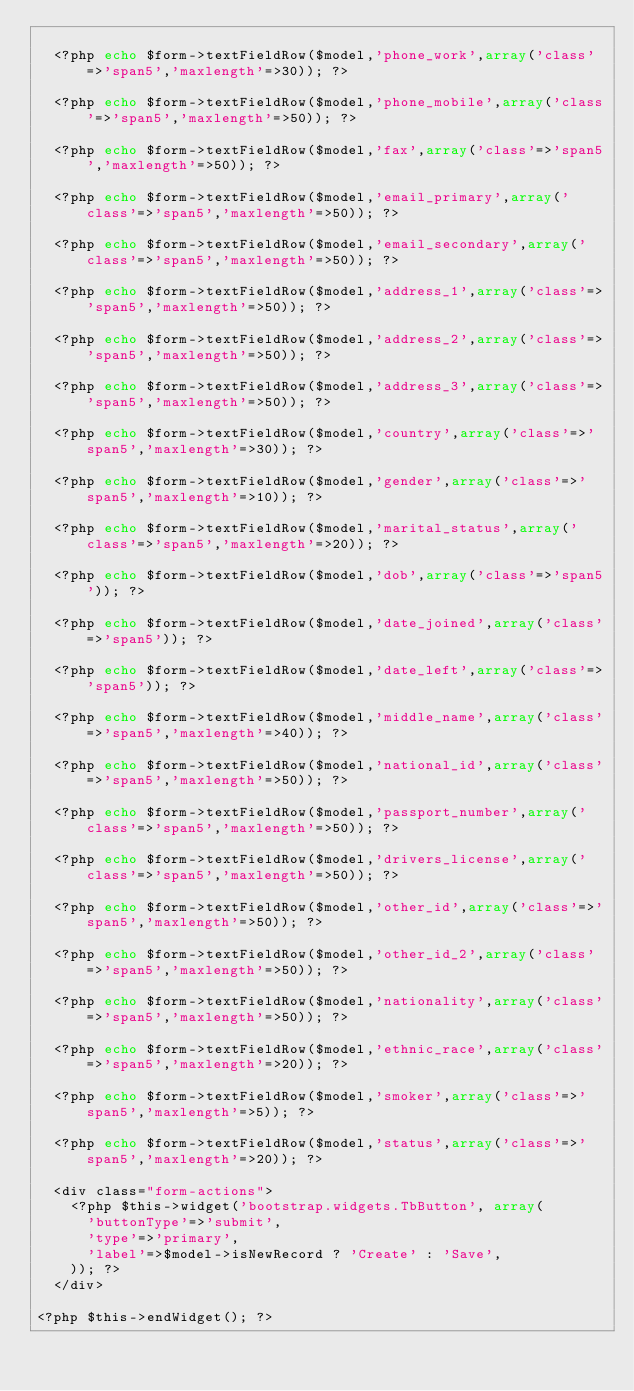<code> <loc_0><loc_0><loc_500><loc_500><_PHP_>
	<?php echo $form->textFieldRow($model,'phone_work',array('class'=>'span5','maxlength'=>30)); ?>

	<?php echo $form->textFieldRow($model,'phone_mobile',array('class'=>'span5','maxlength'=>50)); ?>

	<?php echo $form->textFieldRow($model,'fax',array('class'=>'span5','maxlength'=>50)); ?>

	<?php echo $form->textFieldRow($model,'email_primary',array('class'=>'span5','maxlength'=>50)); ?>

	<?php echo $form->textFieldRow($model,'email_secondary',array('class'=>'span5','maxlength'=>50)); ?>

	<?php echo $form->textFieldRow($model,'address_1',array('class'=>'span5','maxlength'=>50)); ?>

	<?php echo $form->textFieldRow($model,'address_2',array('class'=>'span5','maxlength'=>50)); ?>

	<?php echo $form->textFieldRow($model,'address_3',array('class'=>'span5','maxlength'=>50)); ?>

	<?php echo $form->textFieldRow($model,'country',array('class'=>'span5','maxlength'=>30)); ?>

	<?php echo $form->textFieldRow($model,'gender',array('class'=>'span5','maxlength'=>10)); ?>

	<?php echo $form->textFieldRow($model,'marital_status',array('class'=>'span5','maxlength'=>20)); ?>

	<?php echo $form->textFieldRow($model,'dob',array('class'=>'span5')); ?>

	<?php echo $form->textFieldRow($model,'date_joined',array('class'=>'span5')); ?>

	<?php echo $form->textFieldRow($model,'date_left',array('class'=>'span5')); ?>

	<?php echo $form->textFieldRow($model,'middle_name',array('class'=>'span5','maxlength'=>40)); ?>

	<?php echo $form->textFieldRow($model,'national_id',array('class'=>'span5','maxlength'=>50)); ?>

	<?php echo $form->textFieldRow($model,'passport_number',array('class'=>'span5','maxlength'=>50)); ?>

	<?php echo $form->textFieldRow($model,'drivers_license',array('class'=>'span5','maxlength'=>50)); ?>

	<?php echo $form->textFieldRow($model,'other_id',array('class'=>'span5','maxlength'=>50)); ?>

	<?php echo $form->textFieldRow($model,'other_id_2',array('class'=>'span5','maxlength'=>50)); ?>

	<?php echo $form->textFieldRow($model,'nationality',array('class'=>'span5','maxlength'=>50)); ?>

	<?php echo $form->textFieldRow($model,'ethnic_race',array('class'=>'span5','maxlength'=>20)); ?>

	<?php echo $form->textFieldRow($model,'smoker',array('class'=>'span5','maxlength'=>5)); ?>

	<?php echo $form->textFieldRow($model,'status',array('class'=>'span5','maxlength'=>20)); ?>

	<div class="form-actions">
		<?php $this->widget('bootstrap.widgets.TbButton', array(
			'buttonType'=>'submit',
			'type'=>'primary',
			'label'=>$model->isNewRecord ? 'Create' : 'Save',
		)); ?>
	</div>

<?php $this->endWidget(); ?>
</code> 